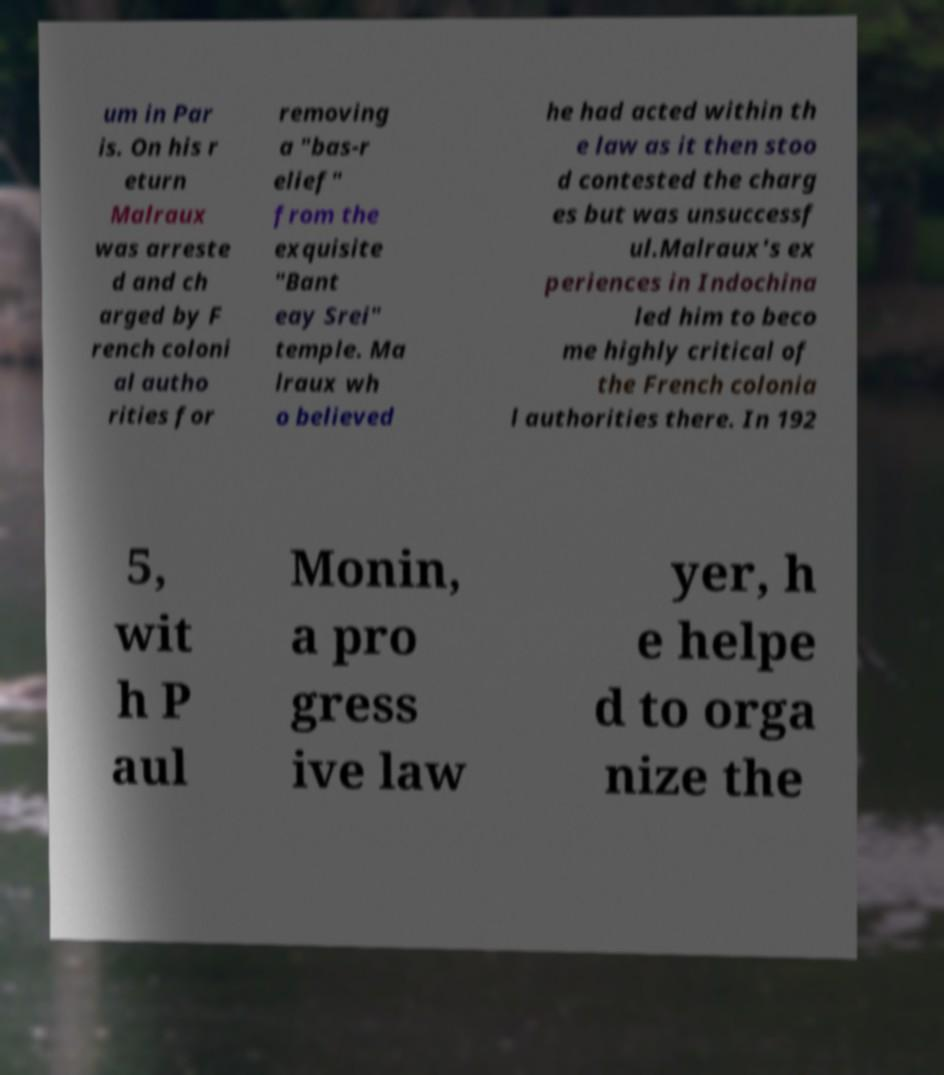I need the written content from this picture converted into text. Can you do that? um in Par is. On his r eturn Malraux was arreste d and ch arged by F rench coloni al autho rities for removing a "bas-r elief" from the exquisite "Bant eay Srei" temple. Ma lraux wh o believed he had acted within th e law as it then stoo d contested the charg es but was unsuccessf ul.Malraux's ex periences in Indochina led him to beco me highly critical of the French colonia l authorities there. In 192 5, wit h P aul Monin, a pro gress ive law yer, h e helpe d to orga nize the 